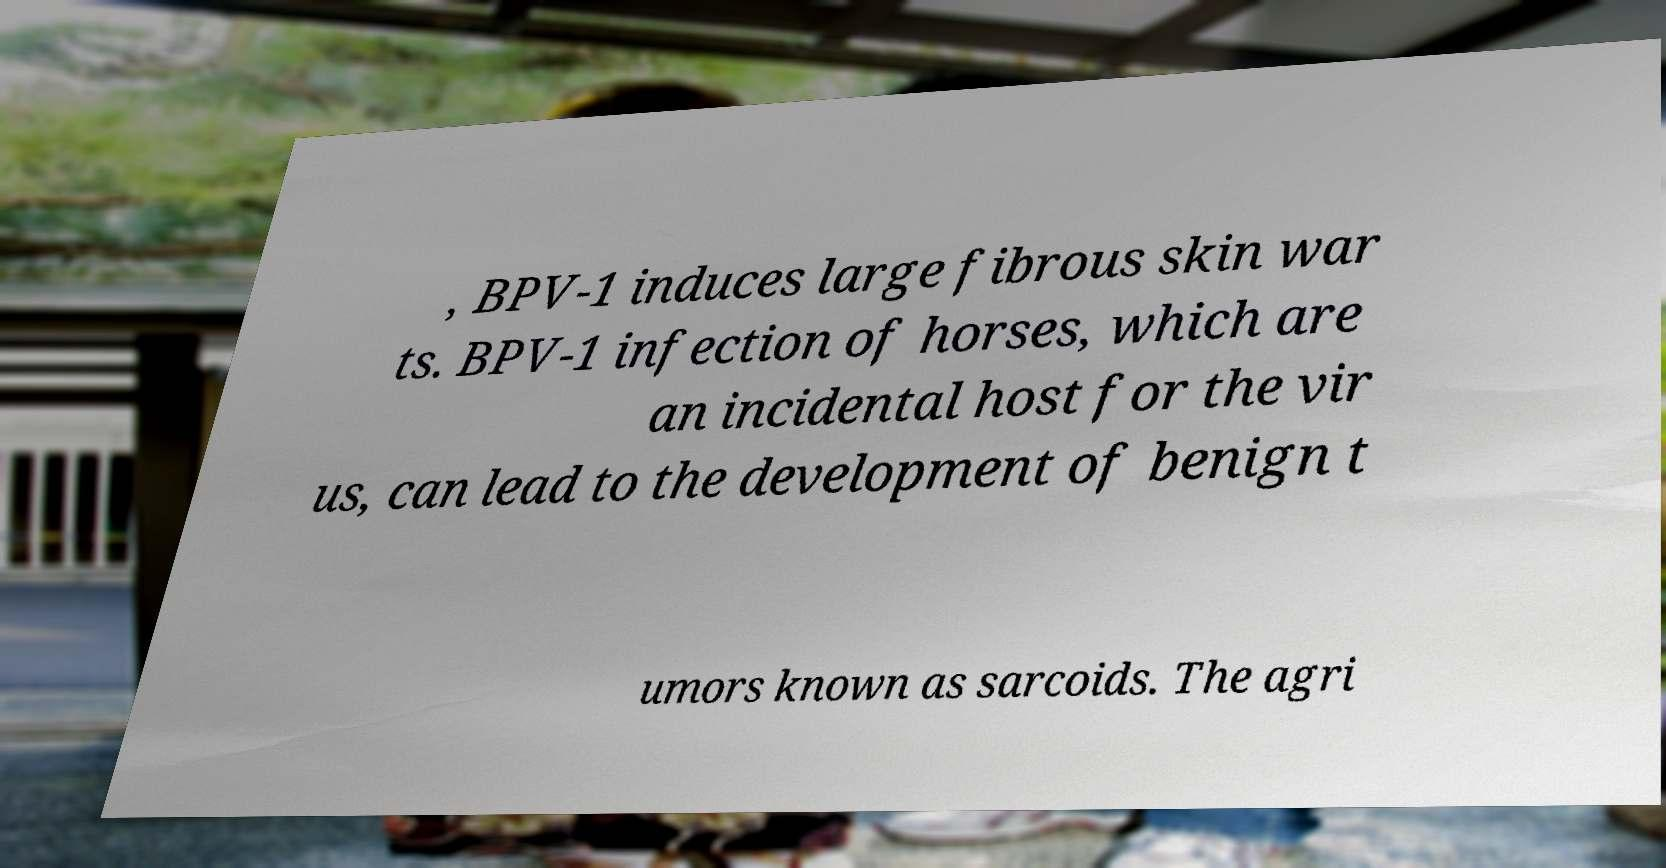Please read and relay the text visible in this image. What does it say? , BPV-1 induces large fibrous skin war ts. BPV-1 infection of horses, which are an incidental host for the vir us, can lead to the development of benign t umors known as sarcoids. The agri 